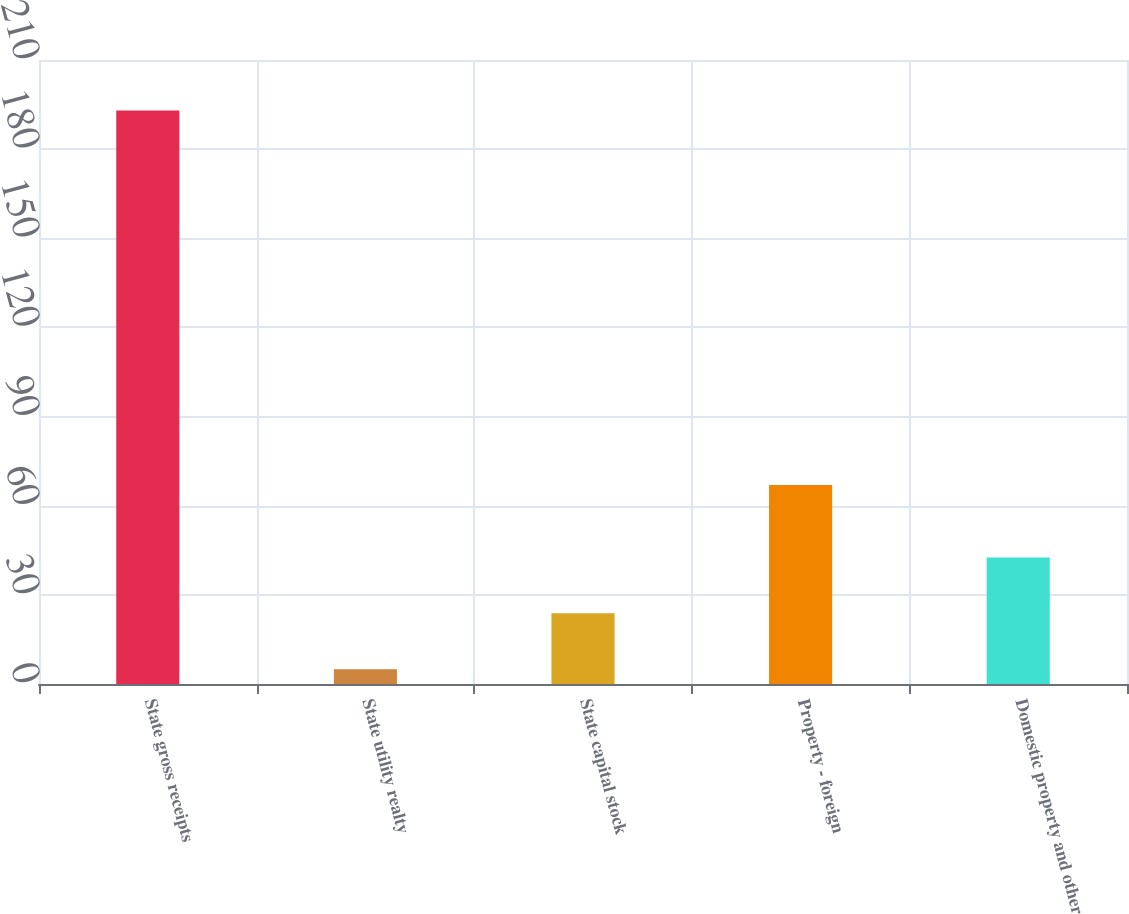<chart> <loc_0><loc_0><loc_500><loc_500><bar_chart><fcel>State gross receipts<fcel>State utility realty<fcel>State capital stock<fcel>Property - foreign<fcel>Domestic property and other<nl><fcel>193<fcel>5<fcel>23.8<fcel>67<fcel>42.6<nl></chart> 